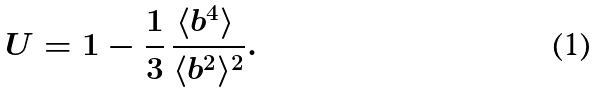<formula> <loc_0><loc_0><loc_500><loc_500>U = 1 - \frac { 1 } { 3 } \, \frac { \langle b ^ { 4 } \rangle ^ { \ } } { \langle b ^ { 2 } \rangle ^ { 2 } } .</formula> 